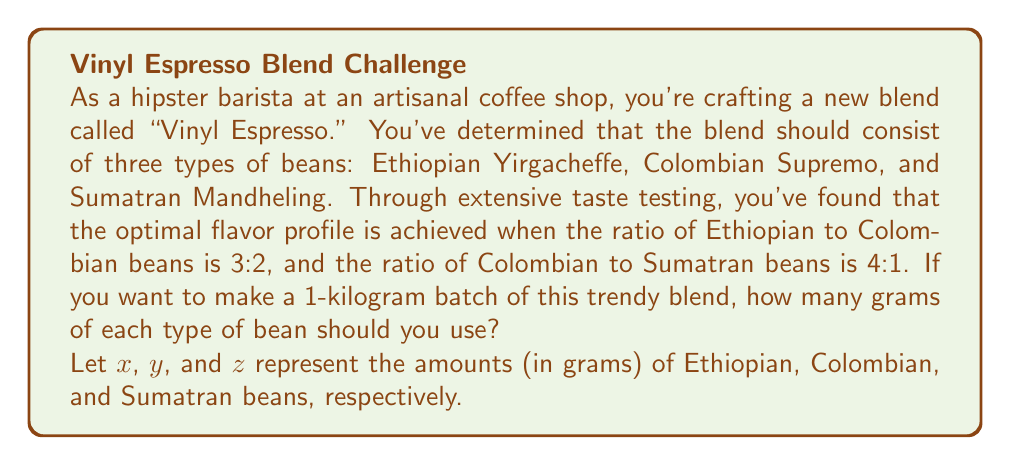Show me your answer to this math problem. Let's approach this problem step-by-step using a system of linear equations:

1) First, we know that the total amount of beans should be 1 kilogram, which is 1000 grams:

   $$x + y + z = 1000$$

2) The ratio of Ethiopian to Colombian beans is 3:2, which can be expressed as:

   $$\frac{x}{y} = \frac{3}{2}$$ or $$2x = 3y$$

3) The ratio of Colombian to Sumatran beans is 4:1, which can be expressed as:

   $$\frac{y}{z} = \frac{4}{1}$$ or $$y = 4z$$

4) From equation 3, we can substitute $y$ with $4z$ in equations 1 and 2:

   $$x + 4z + z = 1000$$ (from equation 1)
   $$2x = 3(4z)$$ (from equation 2)

5) Simplify the second equation:

   $$x + 5z = 1000$$
   $$2x = 12z$$

6) From the second equation, we can express $x$ in terms of $z$:

   $$x = 6z$$

7) Substitute this into the first equation:

   $$6z + 5z = 1000$$
   $$11z = 1000$$

8) Solve for $z$:

   $$z = \frac{1000}{11} \approx 90.91$$

9) Now we can find $x$ and $y$:

   $$x = 6z = 6 * 90.91 \approx 545.45$$
   $$y = 4z = 4 * 90.91 \approx 363.64$$

10) Rounding to the nearest gram (as it's impractical to measure fractions of a gram for coffee beans):

    Ethiopian Yirgacheffe (x): 545 grams
    Colombian Supremo (y): 364 grams
    Sumatran Mandheling (z): 91 grams

    Note: The sum is 1000 grams, as required.
Answer: Ethiopian Yirgacheffe: 545 grams
Colombian Supremo: 364 grams
Sumatran Mandheling: 91 grams 